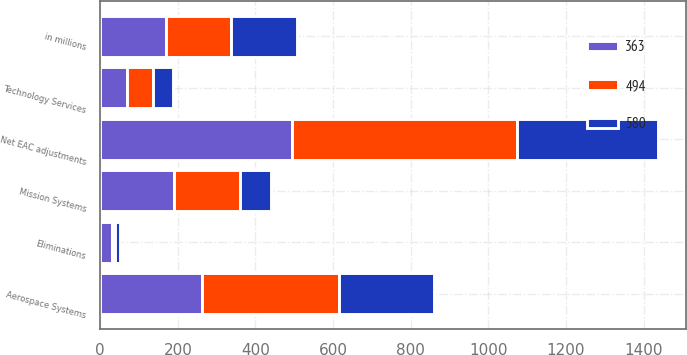<chart> <loc_0><loc_0><loc_500><loc_500><stacked_bar_chart><ecel><fcel>in millions<fcel>Aerospace Systems<fcel>Mission Systems<fcel>Technology Services<fcel>Eliminations<fcel>Net EAC adjustments<nl><fcel>580<fcel>169<fcel>246<fcel>79<fcel>51<fcel>13<fcel>363<nl><fcel>363<fcel>169<fcel>263<fcel>191<fcel>69<fcel>29<fcel>494<nl><fcel>494<fcel>169<fcel>352<fcel>169<fcel>68<fcel>9<fcel>580<nl></chart> 